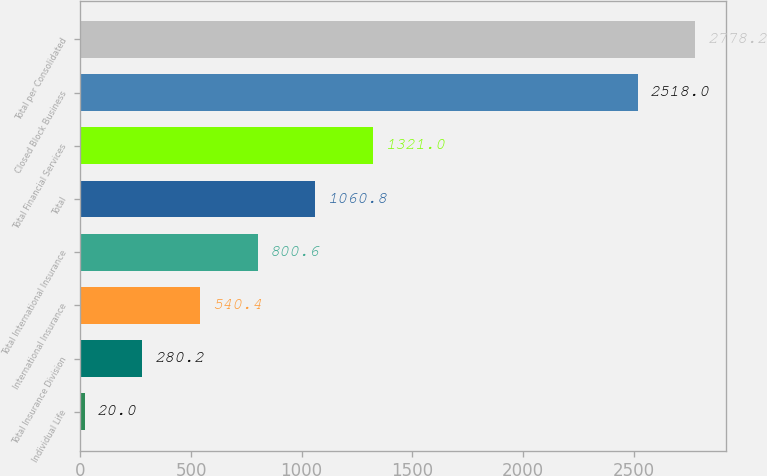Convert chart to OTSL. <chart><loc_0><loc_0><loc_500><loc_500><bar_chart><fcel>Individual Life<fcel>Total Insurance Division<fcel>International Insurance<fcel>Total International Insurance<fcel>Total<fcel>Total Financial Services<fcel>Closed Block Business<fcel>Total per Consolidated<nl><fcel>20<fcel>280.2<fcel>540.4<fcel>800.6<fcel>1060.8<fcel>1321<fcel>2518<fcel>2778.2<nl></chart> 